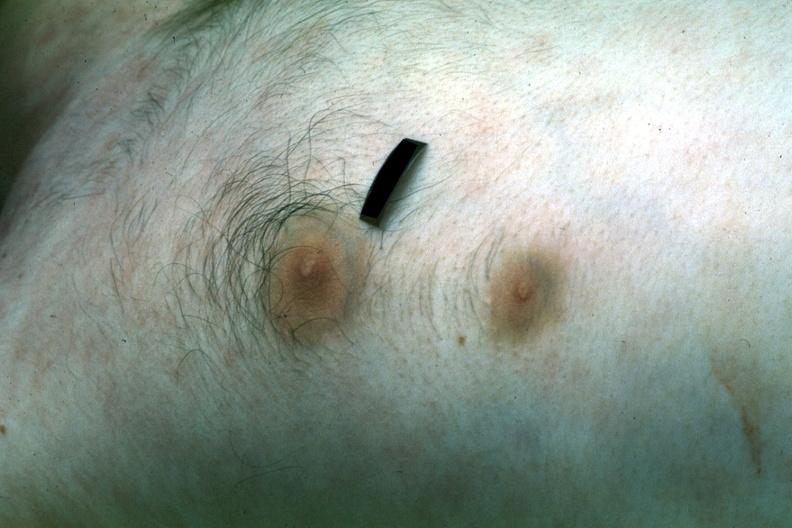s nipple duplication present?
Answer the question using a single word or phrase. Yes 